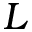<formula> <loc_0><loc_0><loc_500><loc_500>L</formula> 